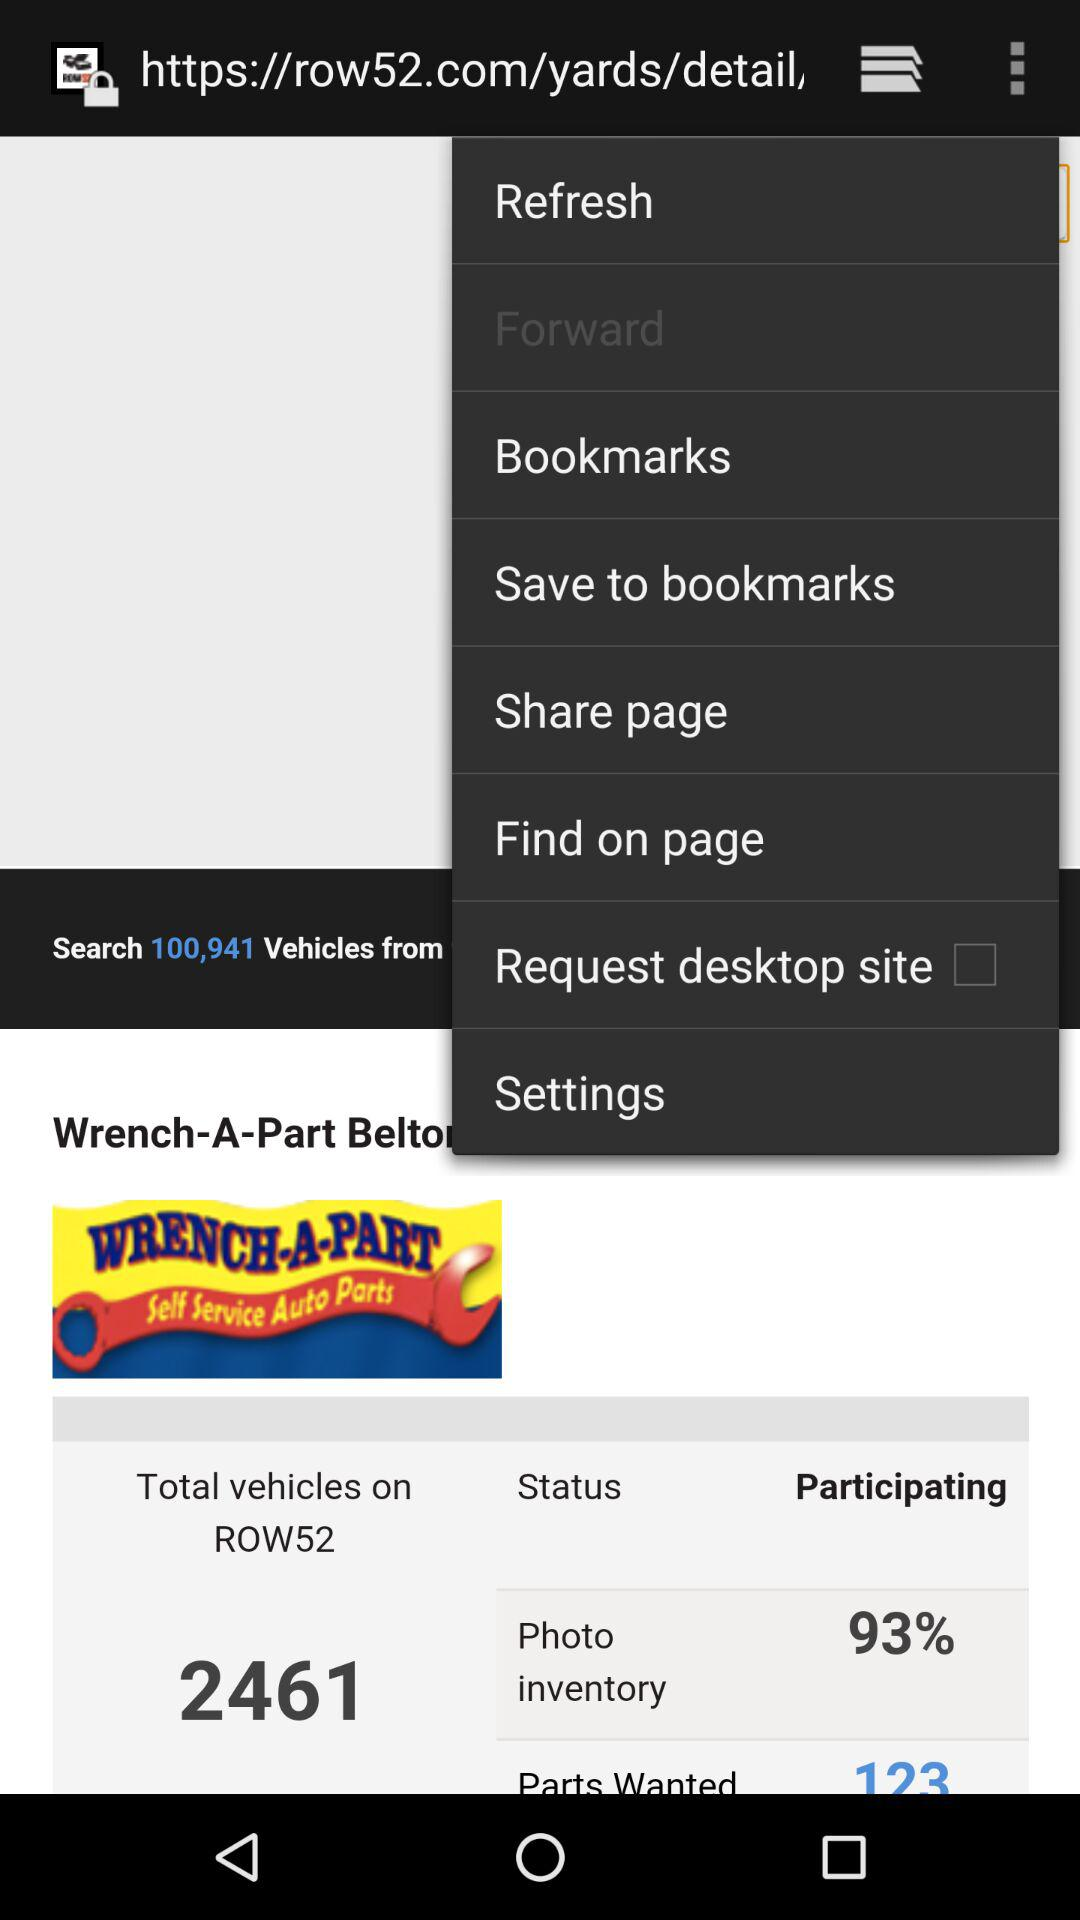What is the total number of vehicles on "ROW52"? The total number of vehicles on "ROW52" is 2461. 